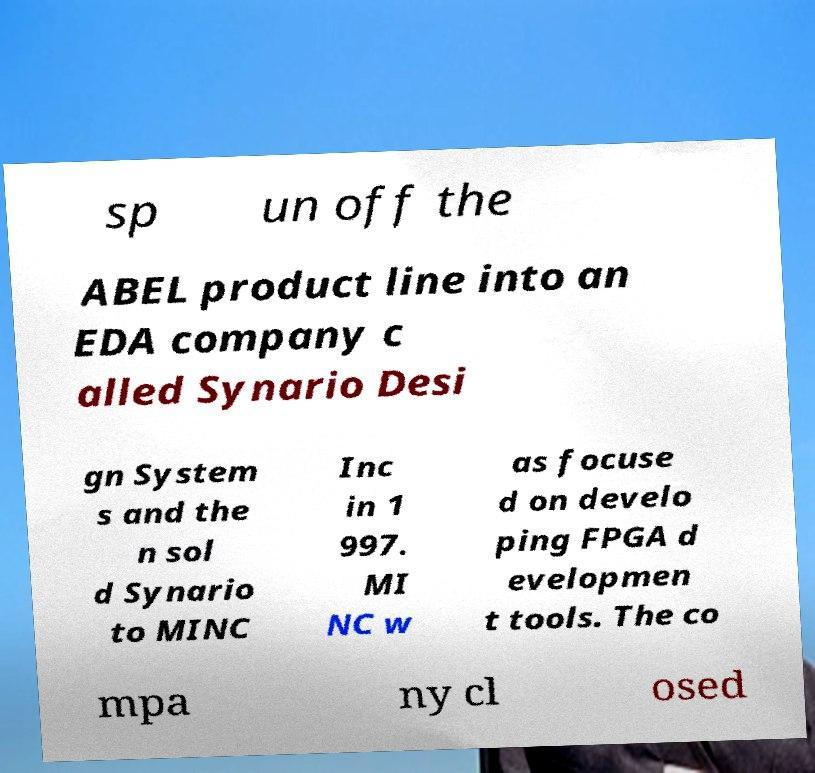Please identify and transcribe the text found in this image. sp un off the ABEL product line into an EDA company c alled Synario Desi gn System s and the n sol d Synario to MINC Inc in 1 997. MI NC w as focuse d on develo ping FPGA d evelopmen t tools. The co mpa ny cl osed 